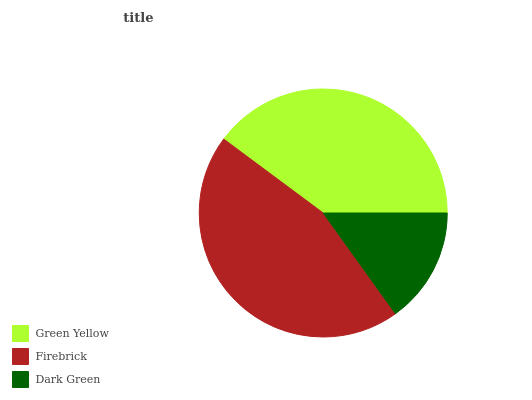Is Dark Green the minimum?
Answer yes or no. Yes. Is Firebrick the maximum?
Answer yes or no. Yes. Is Firebrick the minimum?
Answer yes or no. No. Is Dark Green the maximum?
Answer yes or no. No. Is Firebrick greater than Dark Green?
Answer yes or no. Yes. Is Dark Green less than Firebrick?
Answer yes or no. Yes. Is Dark Green greater than Firebrick?
Answer yes or no. No. Is Firebrick less than Dark Green?
Answer yes or no. No. Is Green Yellow the high median?
Answer yes or no. Yes. Is Green Yellow the low median?
Answer yes or no. Yes. Is Dark Green the high median?
Answer yes or no. No. Is Firebrick the low median?
Answer yes or no. No. 